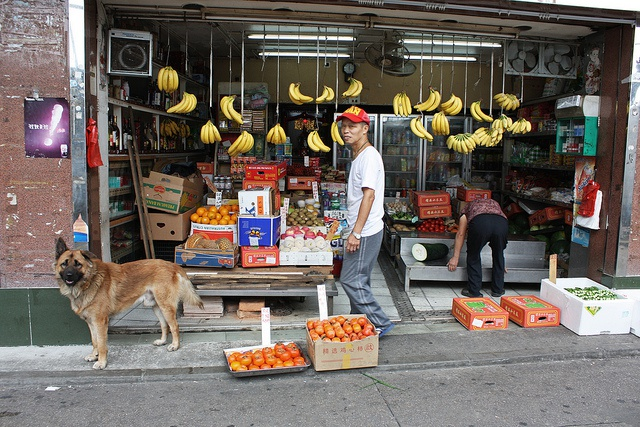Describe the objects in this image and their specific colors. I can see dog in gray, tan, and darkgray tones, people in gray, white, and darkgray tones, banana in gray, black, olive, and khaki tones, people in gray, black, brown, and maroon tones, and orange in gray, red, orange, and tan tones in this image. 